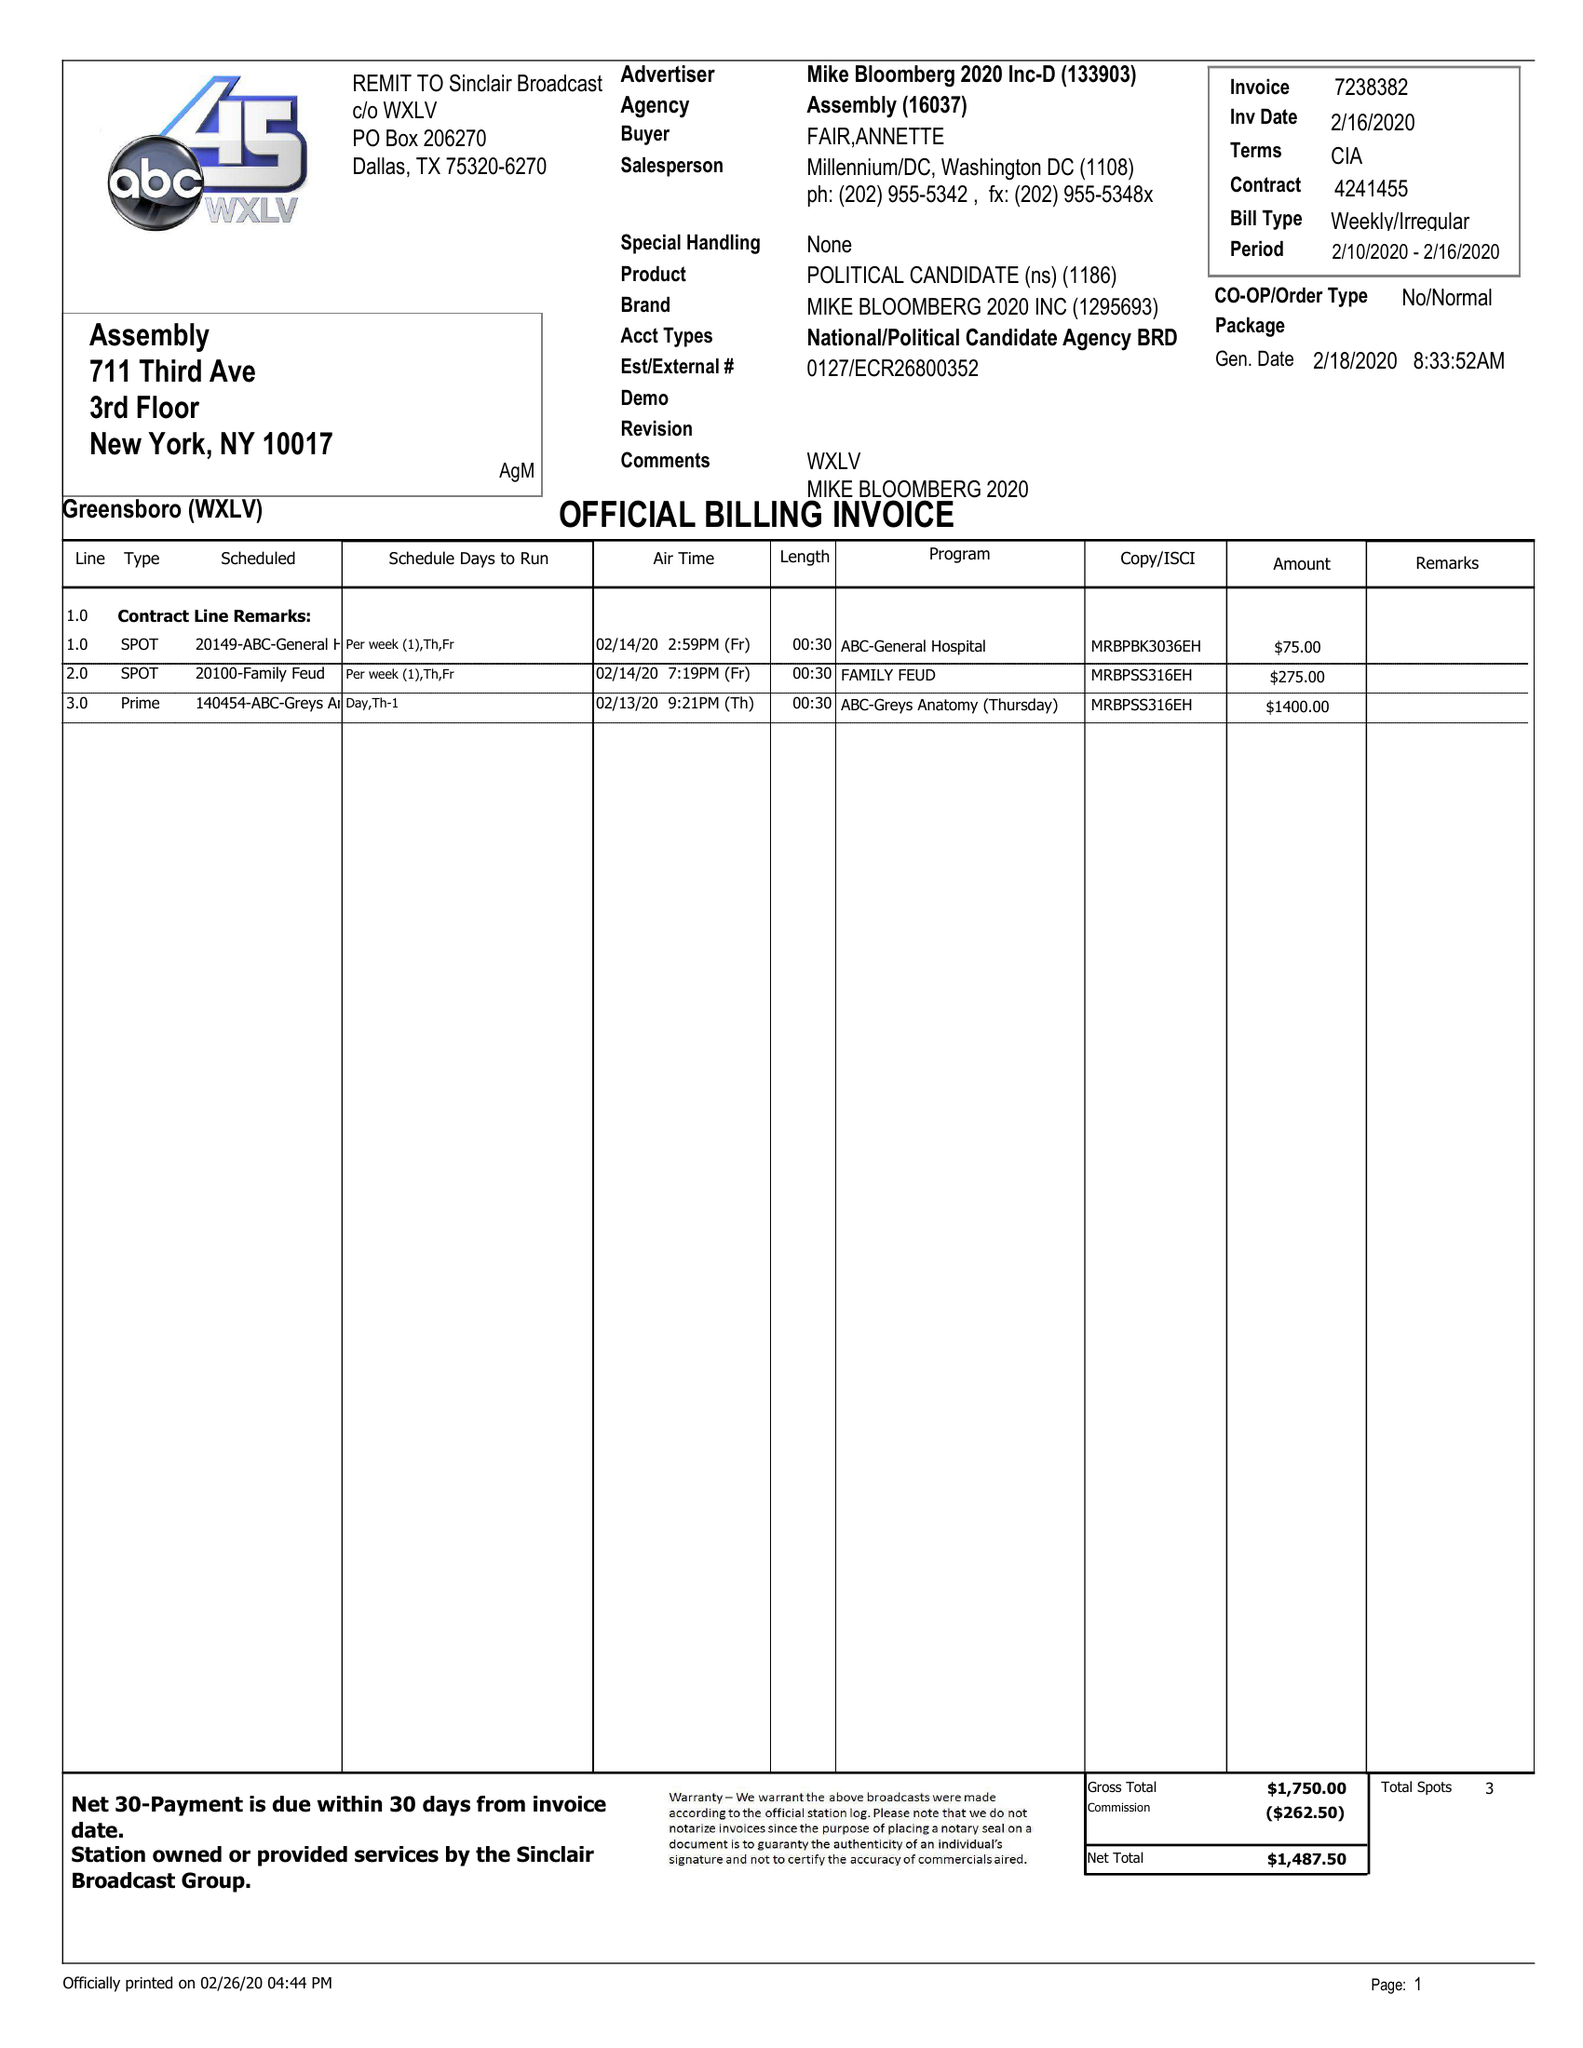What is the value for the gross_amount?
Answer the question using a single word or phrase. 1750.00 